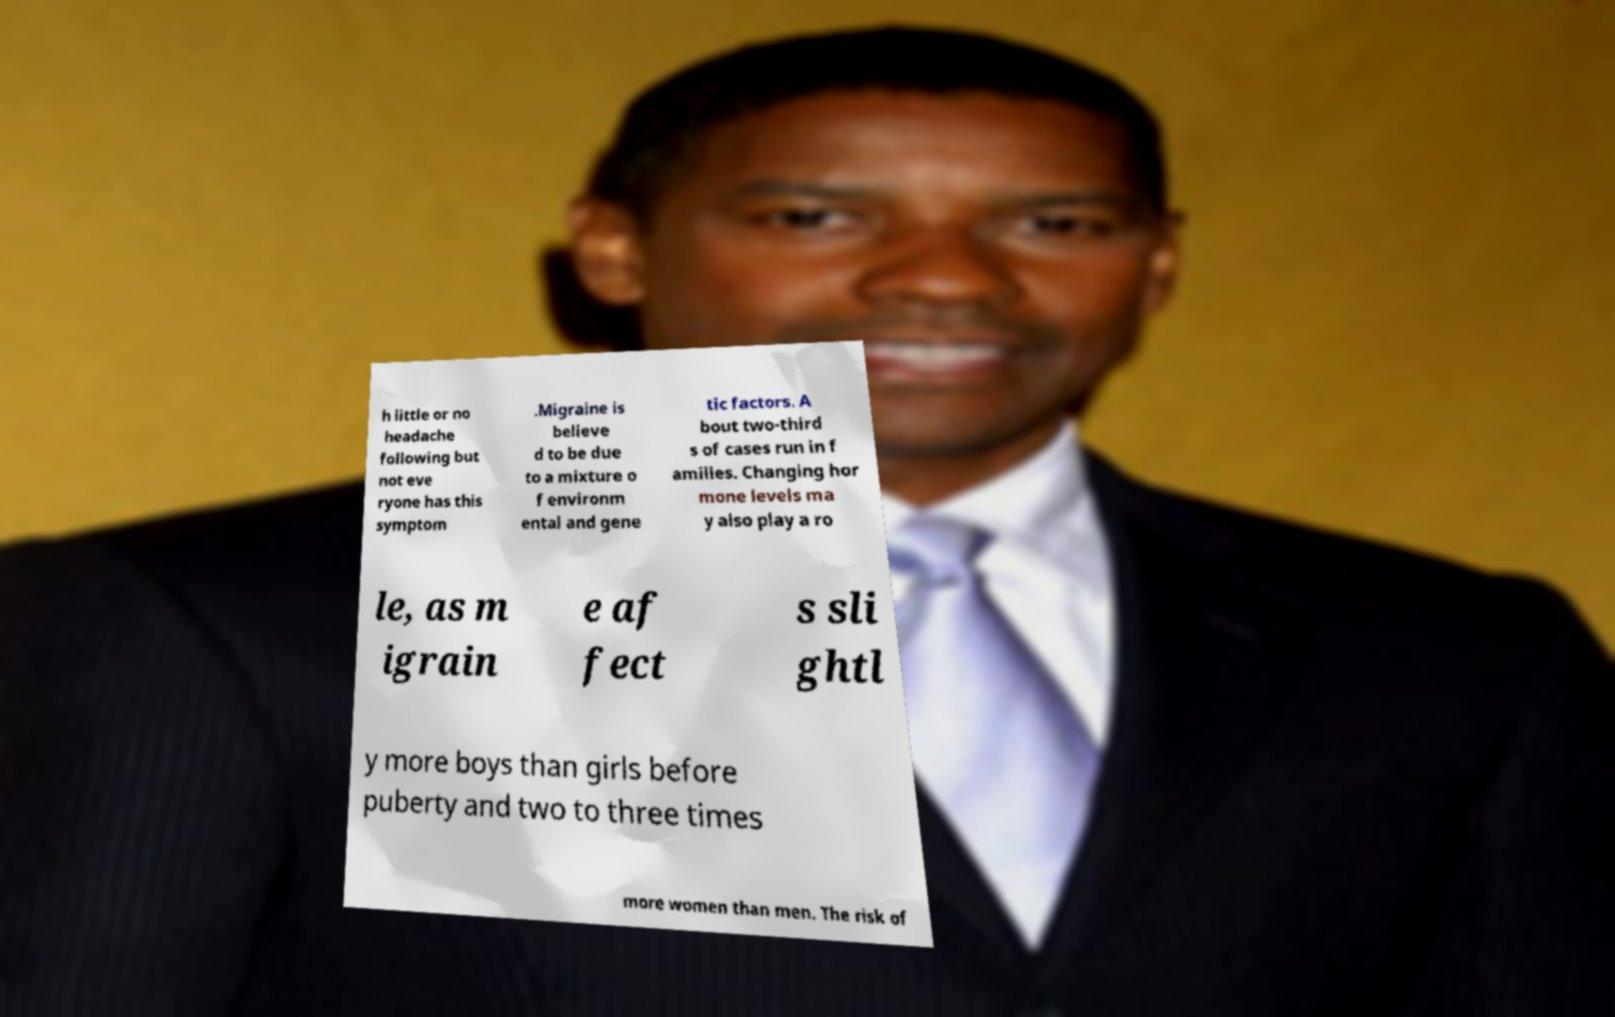Could you extract and type out the text from this image? h little or no headache following but not eve ryone has this symptom .Migraine is believe d to be due to a mixture o f environm ental and gene tic factors. A bout two-third s of cases run in f amilies. Changing hor mone levels ma y also play a ro le, as m igrain e af fect s sli ghtl y more boys than girls before puberty and two to three times more women than men. The risk of 